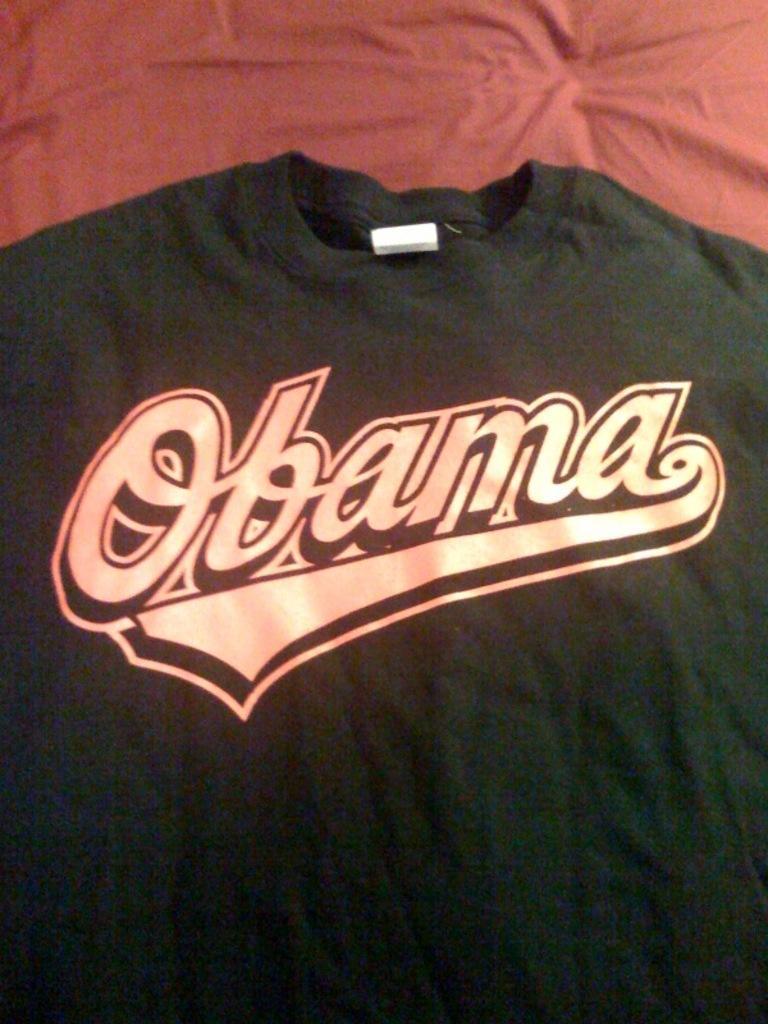Please provide a concise description of this image. In this image I can see a black color t-shirt on which I can see a logo on it. 